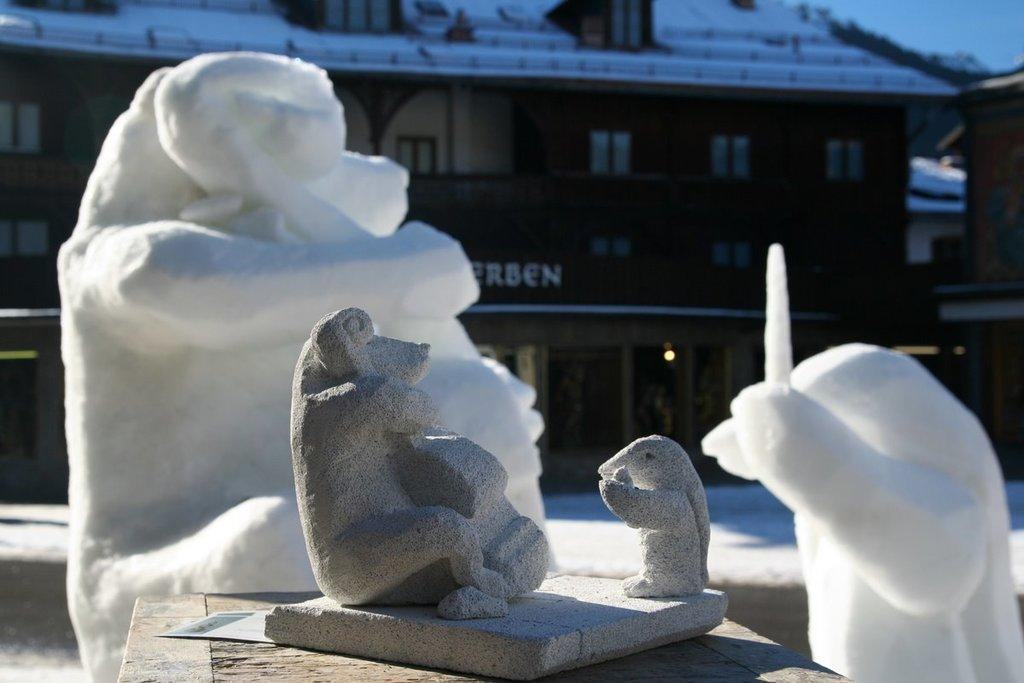What is the main subject in the foreground of the image? There is a stone sculpture on a wooden object in the foreground. What other types of sculptures can be seen in the image? There are snow sculptures behind the stone sculpture. What is visible in the background of the image? There is a building in the background. What is visible at the top of the image? The sky is visible at the top of the image. What type of trade is being conducted in the image? There is no indication of any trade being conducted in the image. Can you describe the driving conditions in the image? There is no reference to driving or vehicles in the image. 